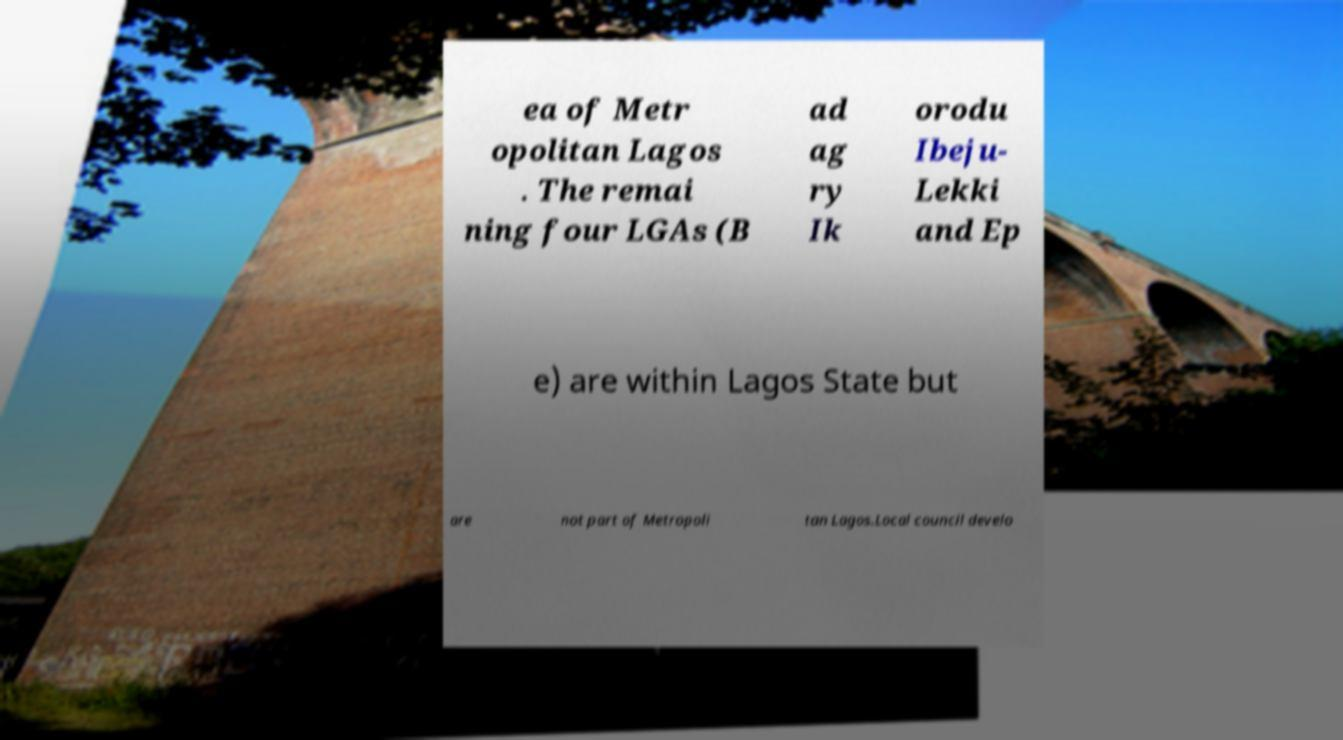I need the written content from this picture converted into text. Can you do that? ea of Metr opolitan Lagos . The remai ning four LGAs (B ad ag ry Ik orodu Ibeju- Lekki and Ep e) are within Lagos State but are not part of Metropoli tan Lagos.Local council develo 